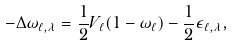Convert formula to latex. <formula><loc_0><loc_0><loc_500><loc_500>- \Delta \omega _ { \ell , \lambda } = \frac { 1 } { 2 } V _ { \ell } ( 1 - \omega _ { \ell } ) - \frac { 1 } { 2 } \epsilon _ { \ell , \lambda } ,</formula> 